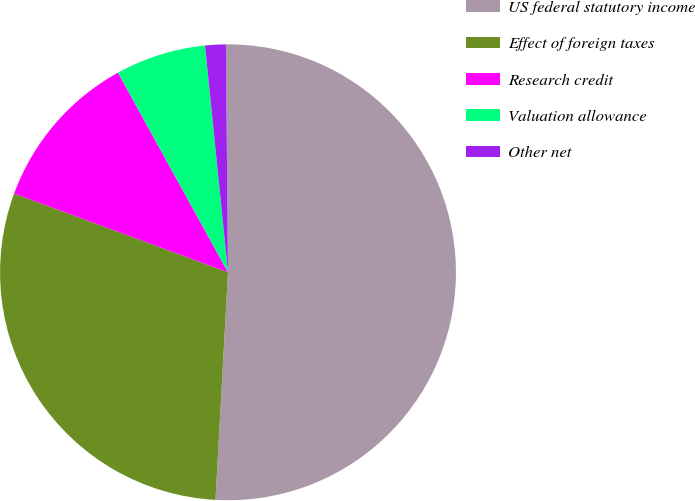<chart> <loc_0><loc_0><loc_500><loc_500><pie_chart><fcel>US federal statutory income<fcel>Effect of foreign taxes<fcel>Research credit<fcel>Valuation allowance<fcel>Other net<nl><fcel>51.02%<fcel>29.74%<fcel>11.37%<fcel>6.41%<fcel>1.46%<nl></chart> 